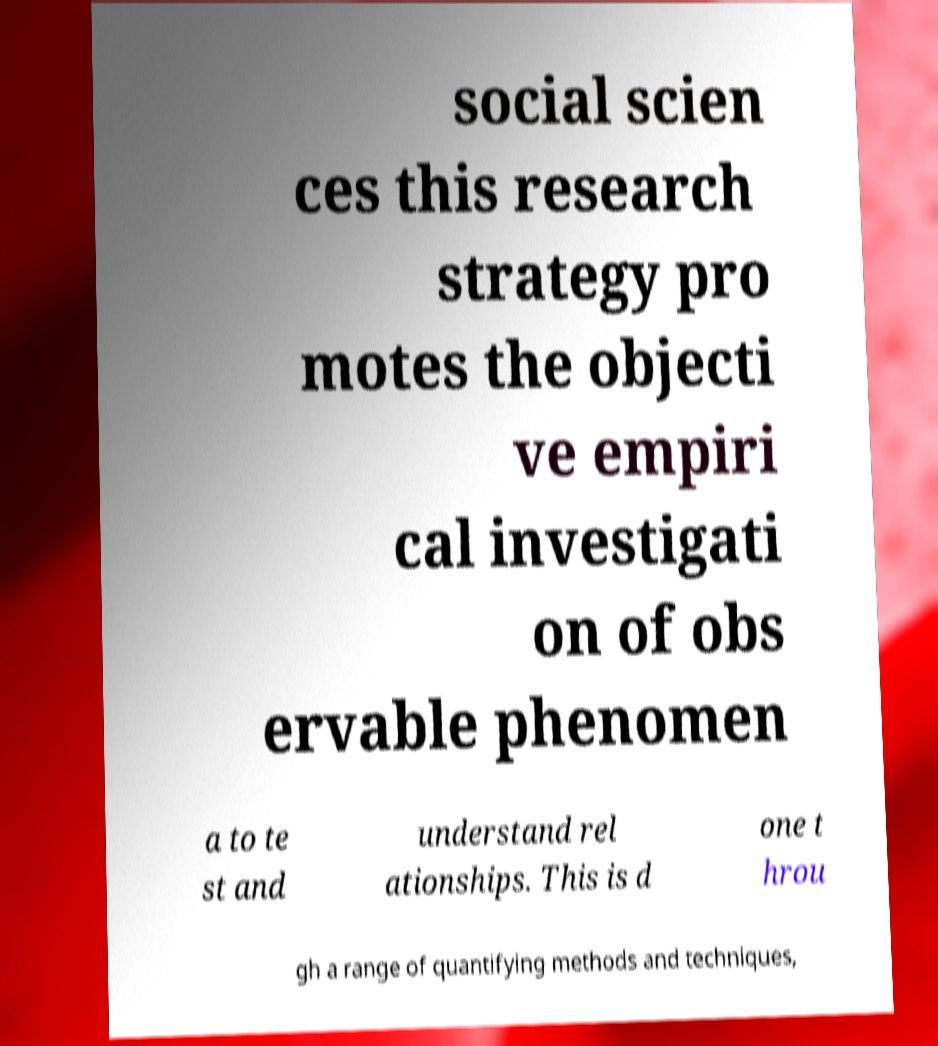Please read and relay the text visible in this image. What does it say? social scien ces this research strategy pro motes the objecti ve empiri cal investigati on of obs ervable phenomen a to te st and understand rel ationships. This is d one t hrou gh a range of quantifying methods and techniques, 